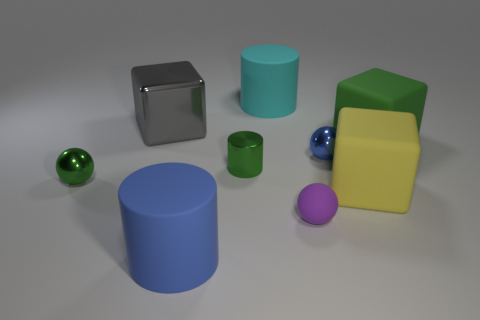Subtract all spheres. How many objects are left? 6 Subtract all tiny green balls. Subtract all big rubber things. How many objects are left? 4 Add 6 small green things. How many small green things are left? 8 Add 9 large blue rubber cylinders. How many large blue rubber cylinders exist? 10 Subtract 1 green spheres. How many objects are left? 8 